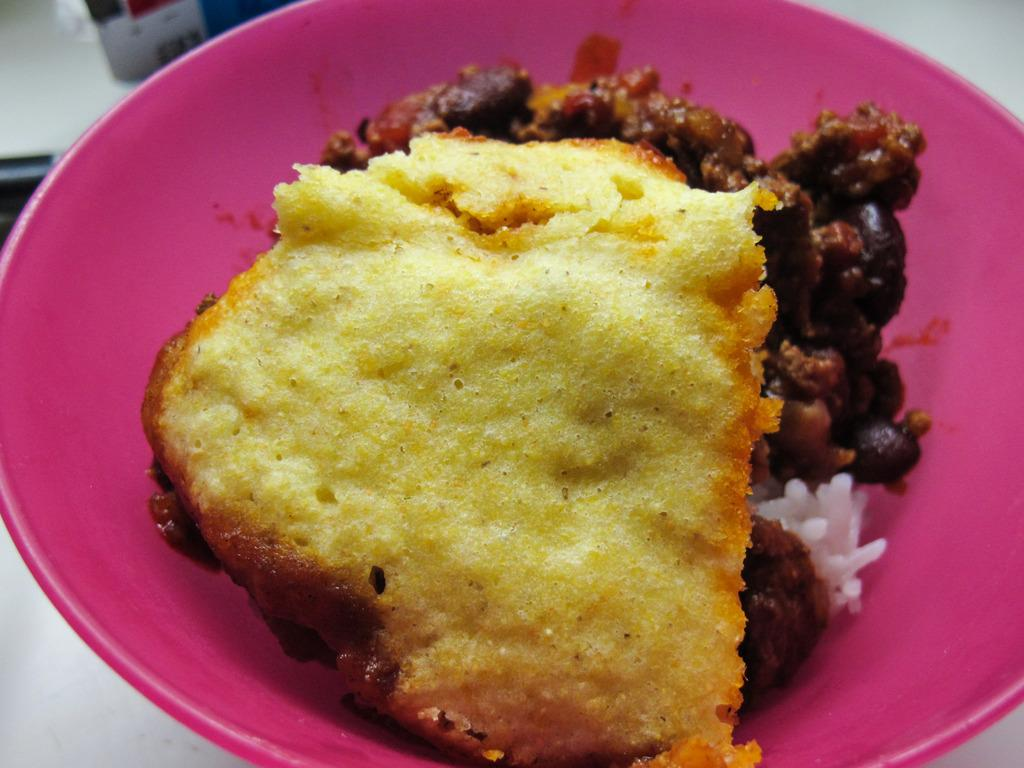What is on the plate that is visible in the image? There is a food item on a plate in the image. Can you describe the object on which the plate is placed? The plate is on an object in the image, but the specific object is not mentioned in the provided facts. What type of act is the food item performing in the image? The food item is not performing any act in the image, as it is an inanimate object. 